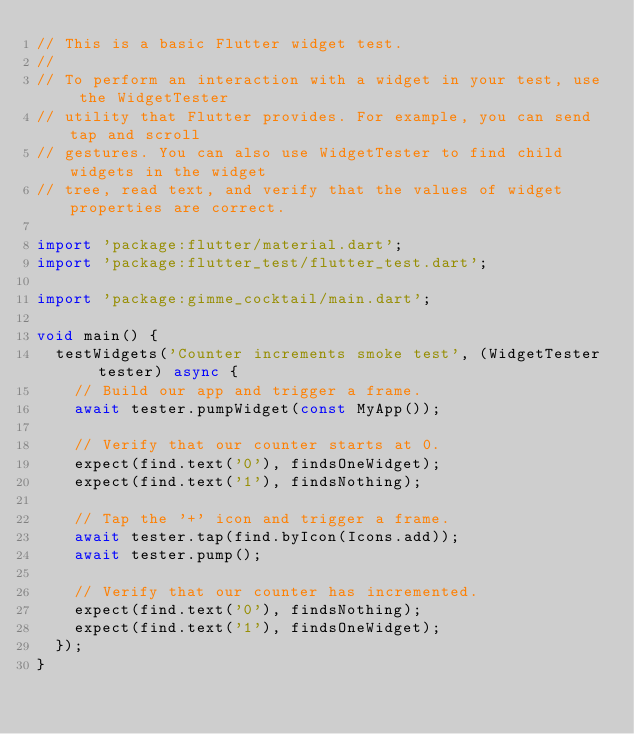<code> <loc_0><loc_0><loc_500><loc_500><_Dart_>// This is a basic Flutter widget test.
//
// To perform an interaction with a widget in your test, use the WidgetTester
// utility that Flutter provides. For example, you can send tap and scroll
// gestures. You can also use WidgetTester to find child widgets in the widget
// tree, read text, and verify that the values of widget properties are correct.

import 'package:flutter/material.dart';
import 'package:flutter_test/flutter_test.dart';

import 'package:gimme_cocktail/main.dart';

void main() {
  testWidgets('Counter increments smoke test', (WidgetTester tester) async {
    // Build our app and trigger a frame.
    await tester.pumpWidget(const MyApp());

    // Verify that our counter starts at 0.
    expect(find.text('0'), findsOneWidget);
    expect(find.text('1'), findsNothing);

    // Tap the '+' icon and trigger a frame.
    await tester.tap(find.byIcon(Icons.add));
    await tester.pump();

    // Verify that our counter has incremented.
    expect(find.text('0'), findsNothing);
    expect(find.text('1'), findsOneWidget);
  });
}
</code> 